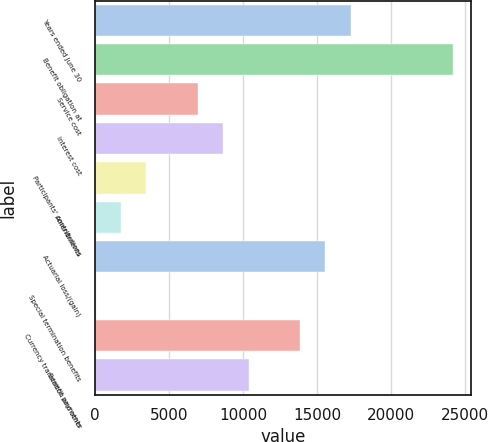<chart> <loc_0><loc_0><loc_500><loc_500><bar_chart><fcel>Years ended June 30<fcel>Benefit obligation at<fcel>Service cost<fcel>Interest cost<fcel>Participants' contributions<fcel>Amendments<fcel>Actuarial loss/(gain)<fcel>Special termination benefits<fcel>Currency translation and other<fcel>Benefit payments<nl><fcel>17285<fcel>24196.6<fcel>6917.6<fcel>8645.5<fcel>3461.8<fcel>1733.9<fcel>15557.1<fcel>6<fcel>13829.2<fcel>10373.4<nl></chart> 